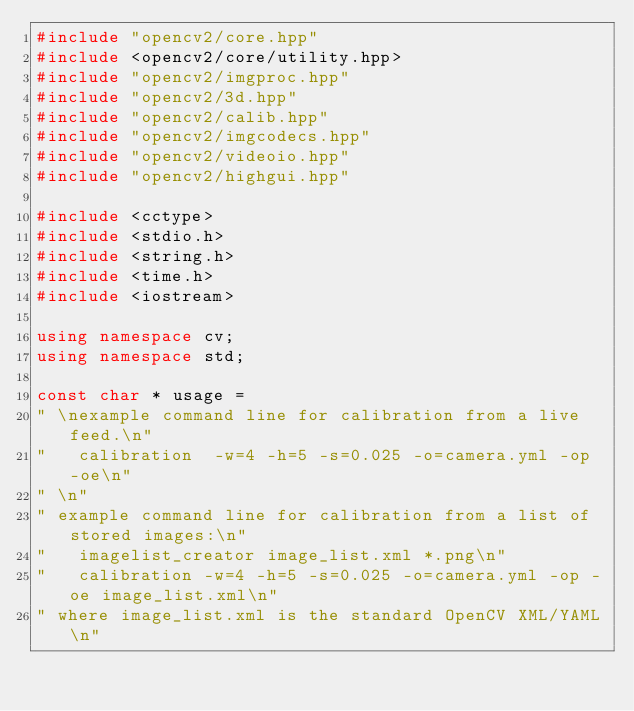Convert code to text. <code><loc_0><loc_0><loc_500><loc_500><_C++_>#include "opencv2/core.hpp"
#include <opencv2/core/utility.hpp>
#include "opencv2/imgproc.hpp"
#include "opencv2/3d.hpp"
#include "opencv2/calib.hpp"
#include "opencv2/imgcodecs.hpp"
#include "opencv2/videoio.hpp"
#include "opencv2/highgui.hpp"

#include <cctype>
#include <stdio.h>
#include <string.h>
#include <time.h>
#include <iostream>

using namespace cv;
using namespace std;

const char * usage =
" \nexample command line for calibration from a live feed.\n"
"   calibration  -w=4 -h=5 -s=0.025 -o=camera.yml -op -oe\n"
" \n"
" example command line for calibration from a list of stored images:\n"
"   imagelist_creator image_list.xml *.png\n"
"   calibration -w=4 -h=5 -s=0.025 -o=camera.yml -op -oe image_list.xml\n"
" where image_list.xml is the standard OpenCV XML/YAML\n"</code> 